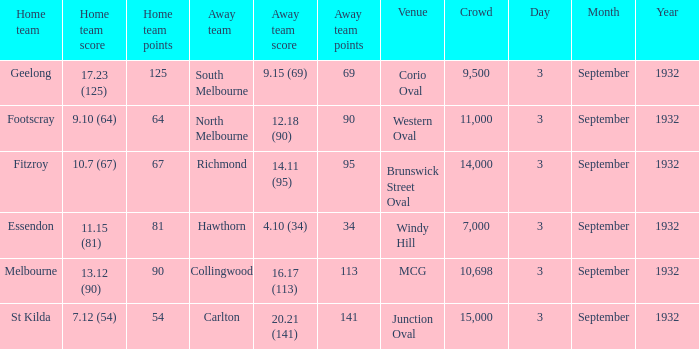What date is listed for the team that has an Away team score of 20.21 (141)? 3 September 1932. 